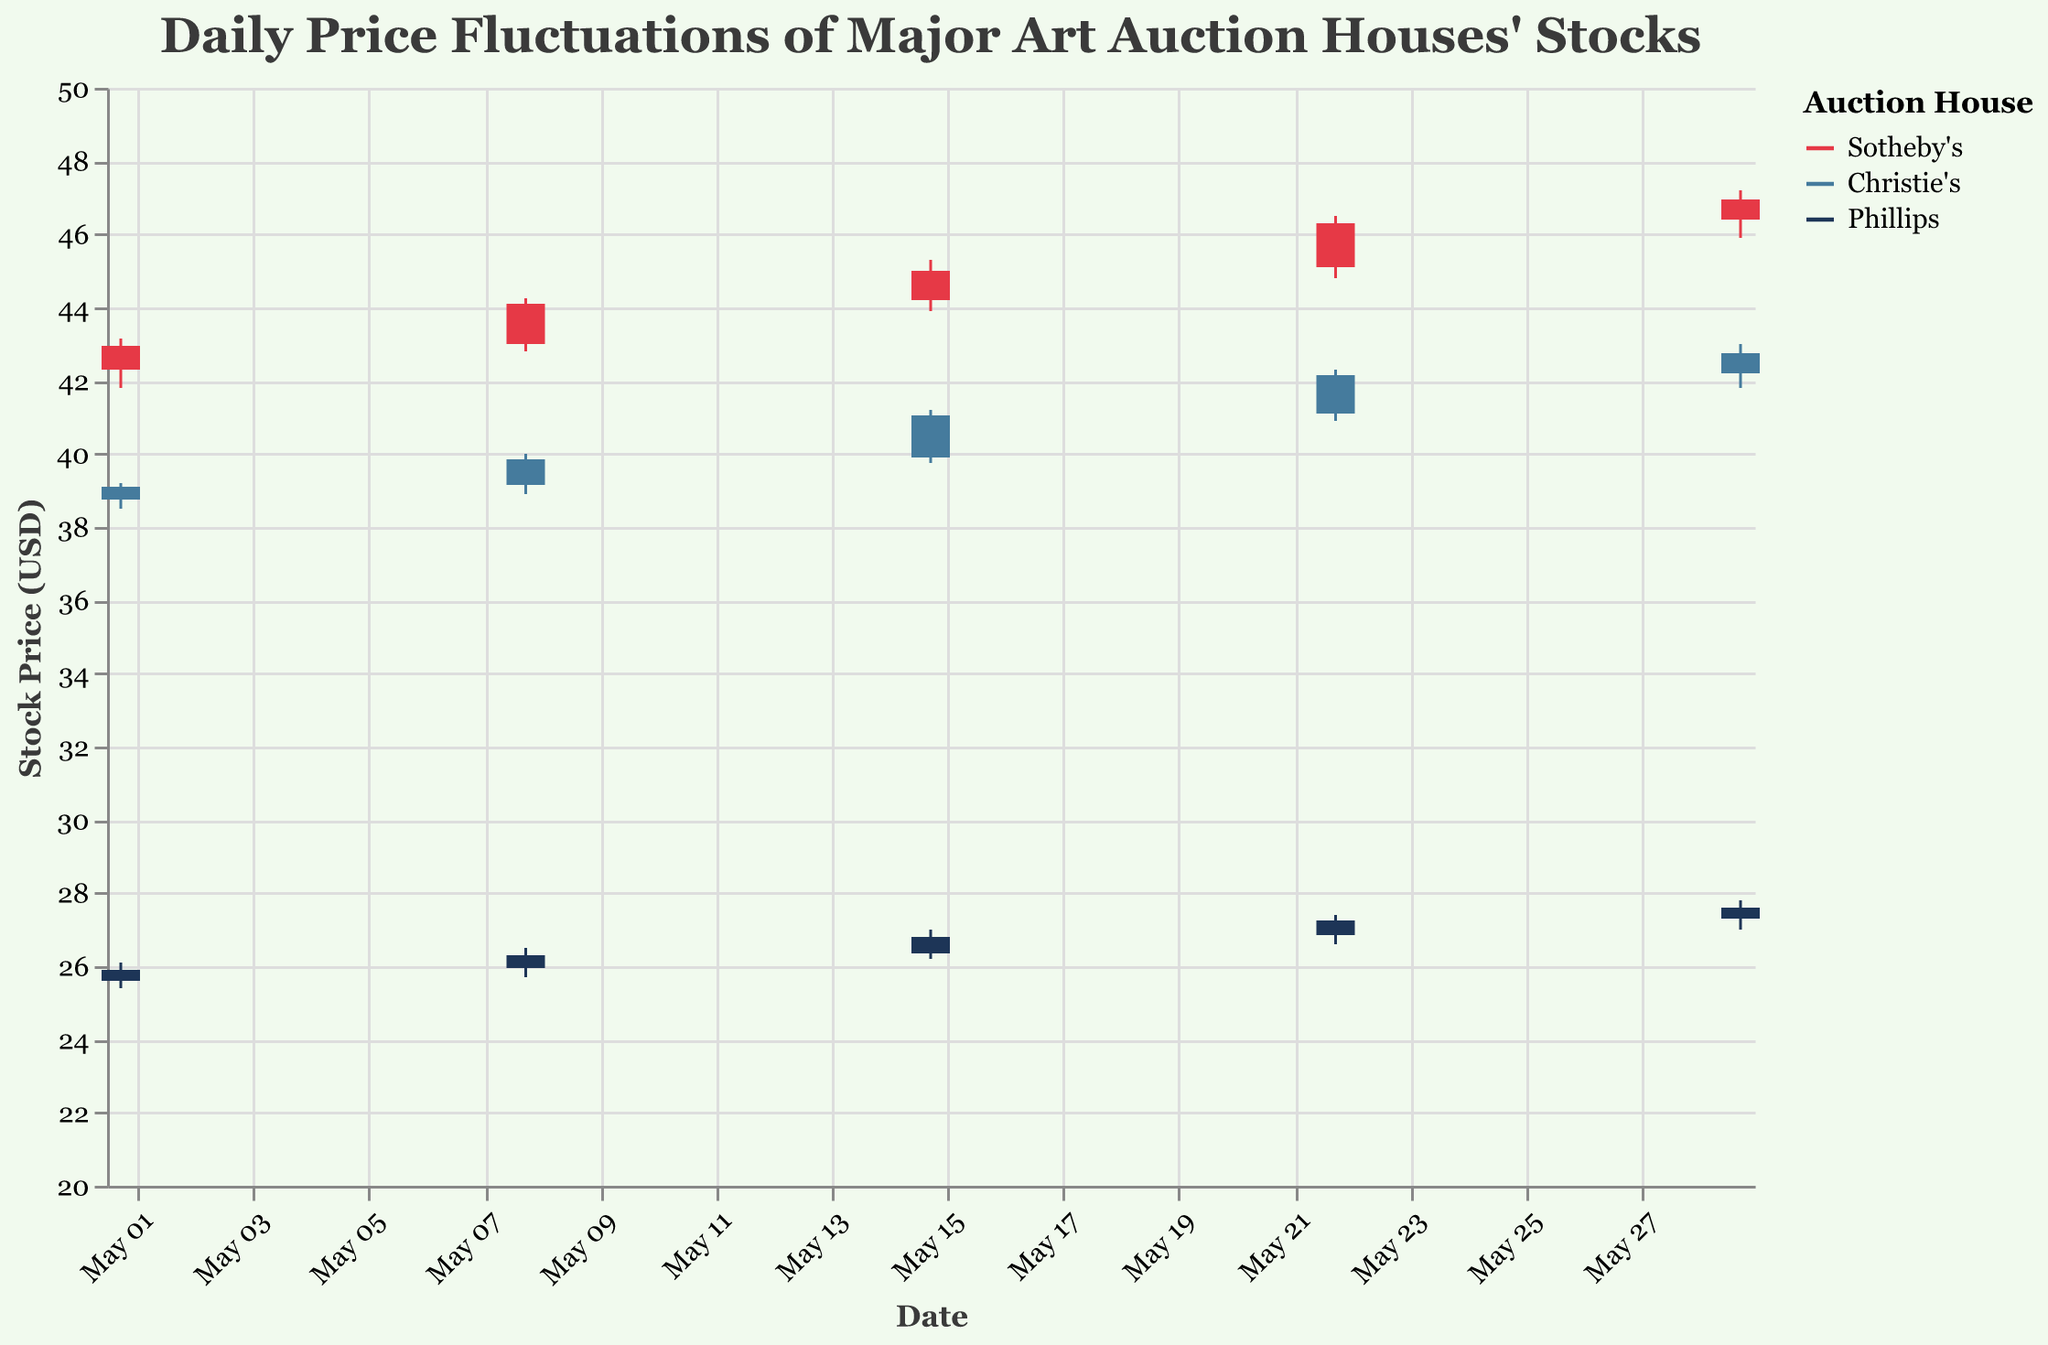What's the title of the plot? The title is typically displayed at the top of the figure and serves to describe the content of the plot. Here, it is "Daily Price Fluctuations of Major Art Auction Houses' Stocks".
Answer: Daily Price Fluctuations of Major Art Auction Houses' Stocks Which company has the highest stock price on May 15th? May 15th shows the data points for Sotheby's, Christie's, and Phillips. Sotheby's has the highest closing price of $45.00.
Answer: Sotheby's What is the difference between the highest and lowest stock prices for Christie's on May 22nd? On May 22nd, Christie's highest price is $42.30, and the lowest price is $40.90. The difference is $42.30 - $40.90 = $1.40.
Answer: $1.40 How did Sotheby's stock price change from May 1st to May 29th? On May 1st, Sotheby's stock closed at $42.95. On May 29th, it closed at $46.95. The change is $46.95 - $42.95 = $4.00.
Answer: Increased by $4.00 What is the average closing price for Phillips over the month? Averaging the closing prices for Phillips: ($25.90 + $26.30 + $26.80 + $27.25 + $27.60) / 5 = $26.77.
Answer: $26.77 Which company had the smallest range of stock prices on May 1st? On May 1st, the ranges are: Sotheby's (1.35), Christie's (0.70), and Phillips (0.70). Both Christie's and Phillips have the smallest range of $0.70.
Answer: Christie's and Phillips Did any company's stock price close lower than it opened on any date? By examining each date, we see that on each occasion, the closing prices are equal to or higher than the opening prices for all companies.
Answer: No Which company had the most significant increase in closing prices between two consecutive dates? Comparing the increases: Sotheby's increased from $42.95 to $44.10 from May 1st to May 8th ($1.15), and then to $45.00 from May 8th to May 15th ($0.90), to $46.30 from May 15th to May 22nd ($1.30), and finally to $46.95 from May 22nd to May 29th ($0.65). The biggest increase is from May 1st to May 8th. Christie's and Phillips do not exhibit a greater single increase.
Answer: Sotheby's from May 22nd to May 29th What trend can you observe in Phillips' stock price over the month? Phillips' stock shows a consistent increase over the recorded dates: $25.90, $26.30, $26.80, $27.25, and $27.60. This indicates a steady upward trend.
Answer: Consistent upward trend 